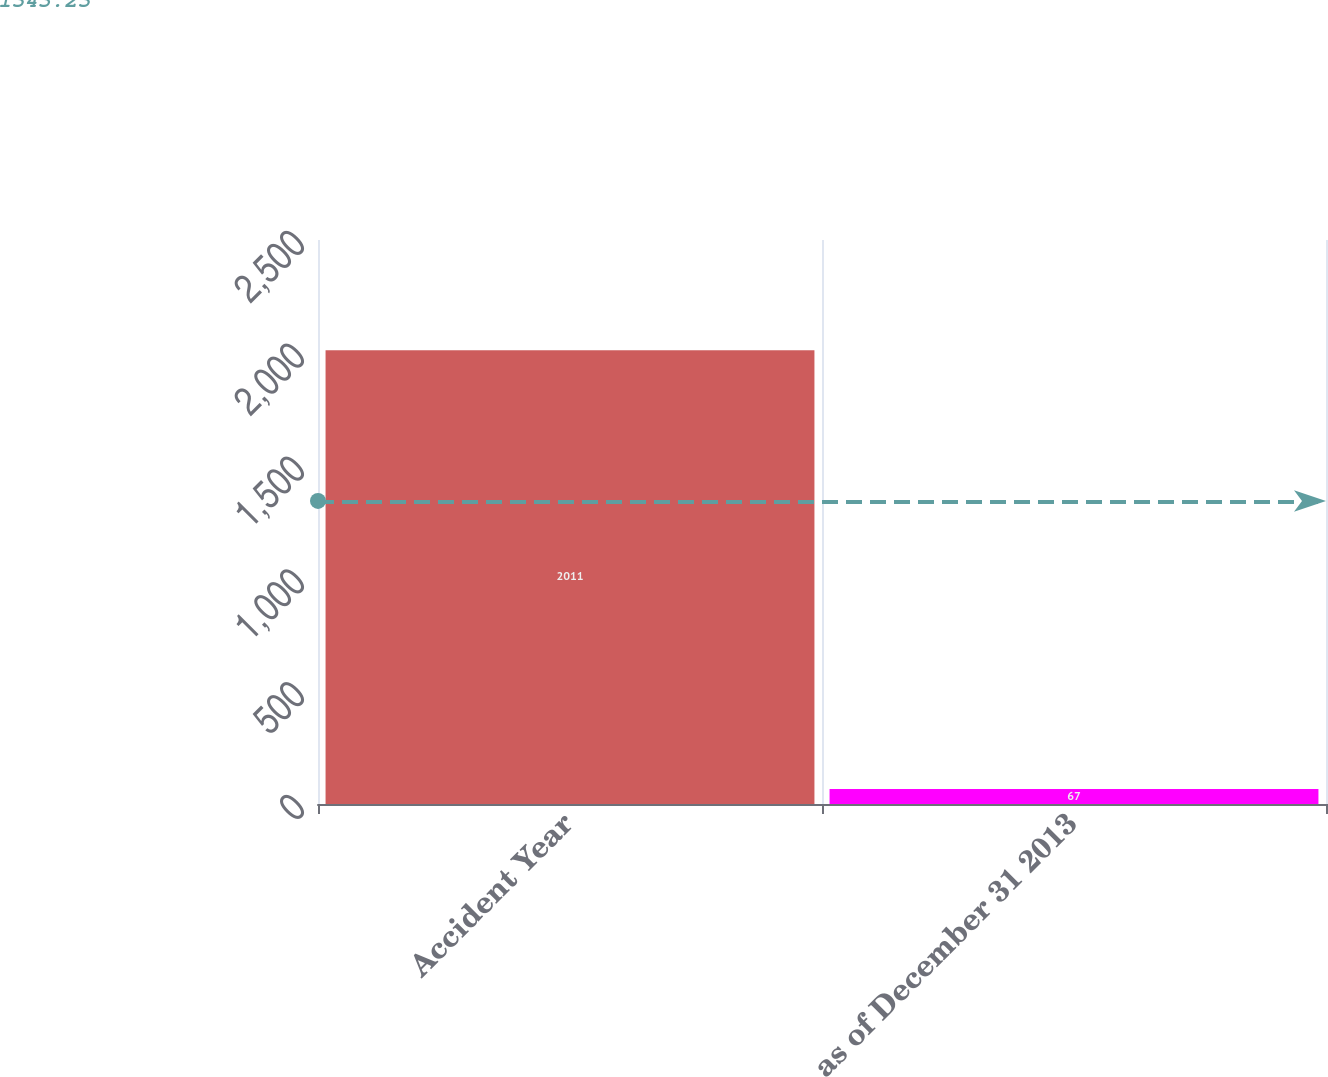Convert chart to OTSL. <chart><loc_0><loc_0><loc_500><loc_500><bar_chart><fcel>Accident Year<fcel>as of December 31 2013<nl><fcel>2011<fcel>67<nl></chart> 